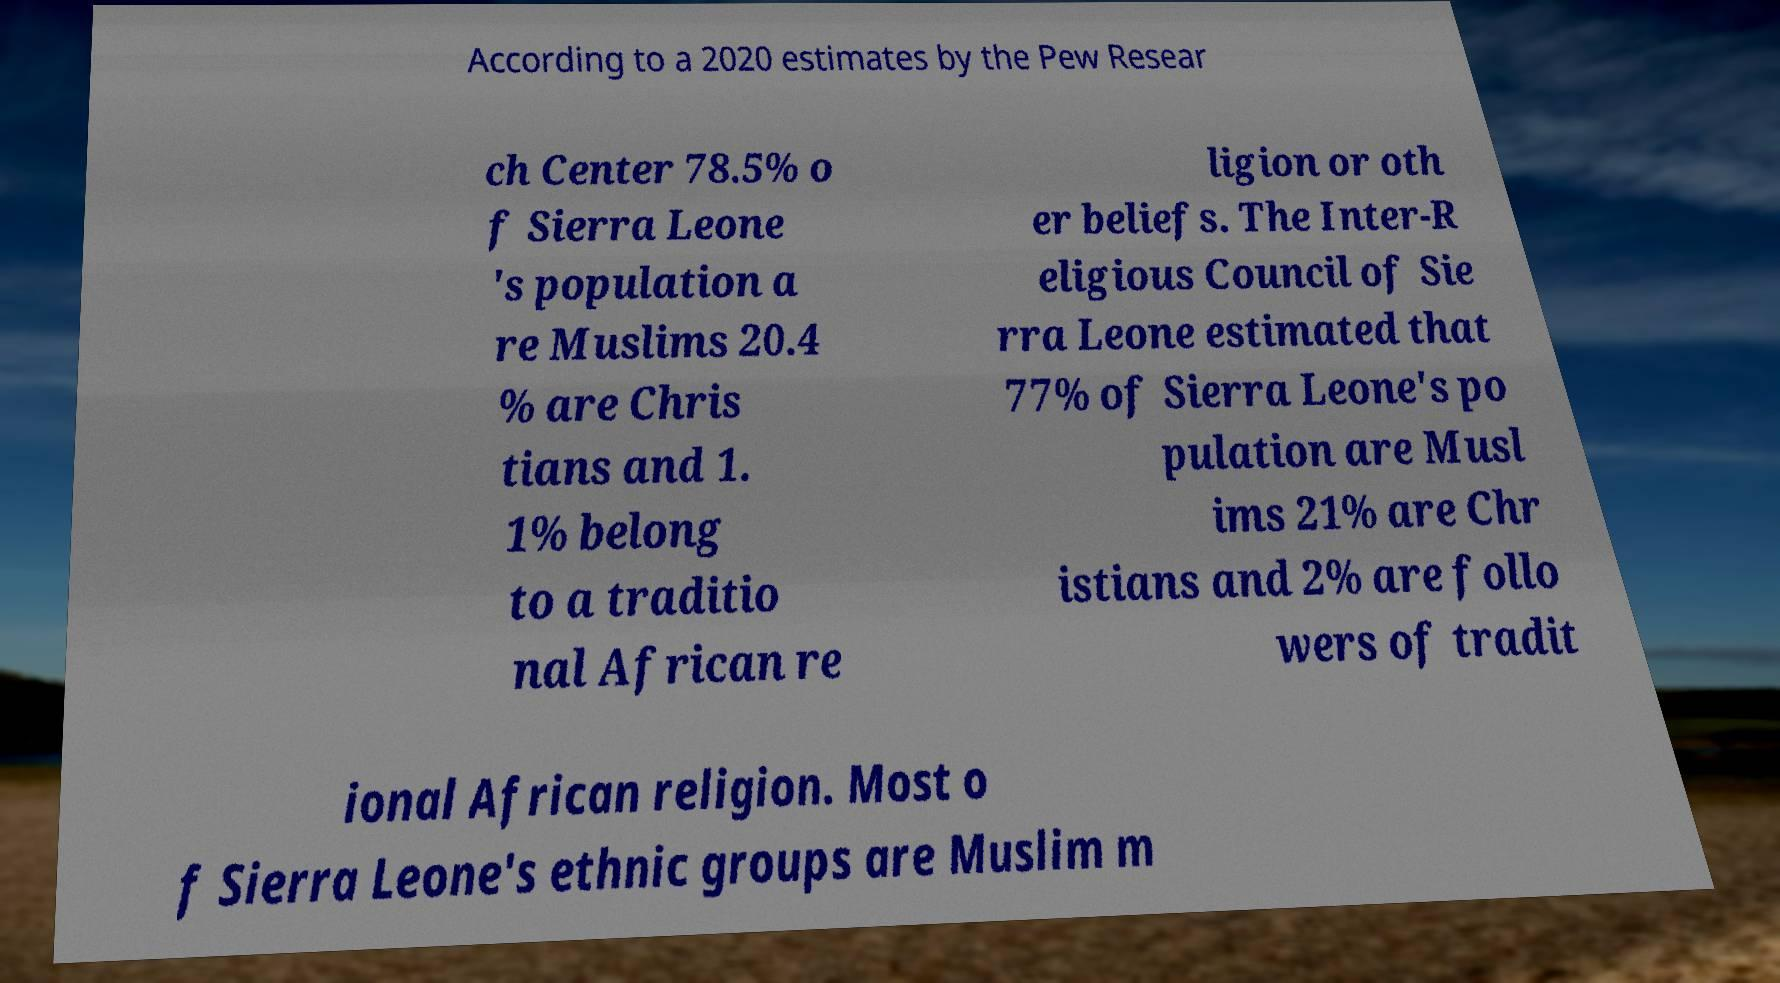Please read and relay the text visible in this image. What does it say? According to a 2020 estimates by the Pew Resear ch Center 78.5% o f Sierra Leone 's population a re Muslims 20.4 % are Chris tians and 1. 1% belong to a traditio nal African re ligion or oth er beliefs. The Inter-R eligious Council of Sie rra Leone estimated that 77% of Sierra Leone's po pulation are Musl ims 21% are Chr istians and 2% are follo wers of tradit ional African religion. Most o f Sierra Leone's ethnic groups are Muslim m 